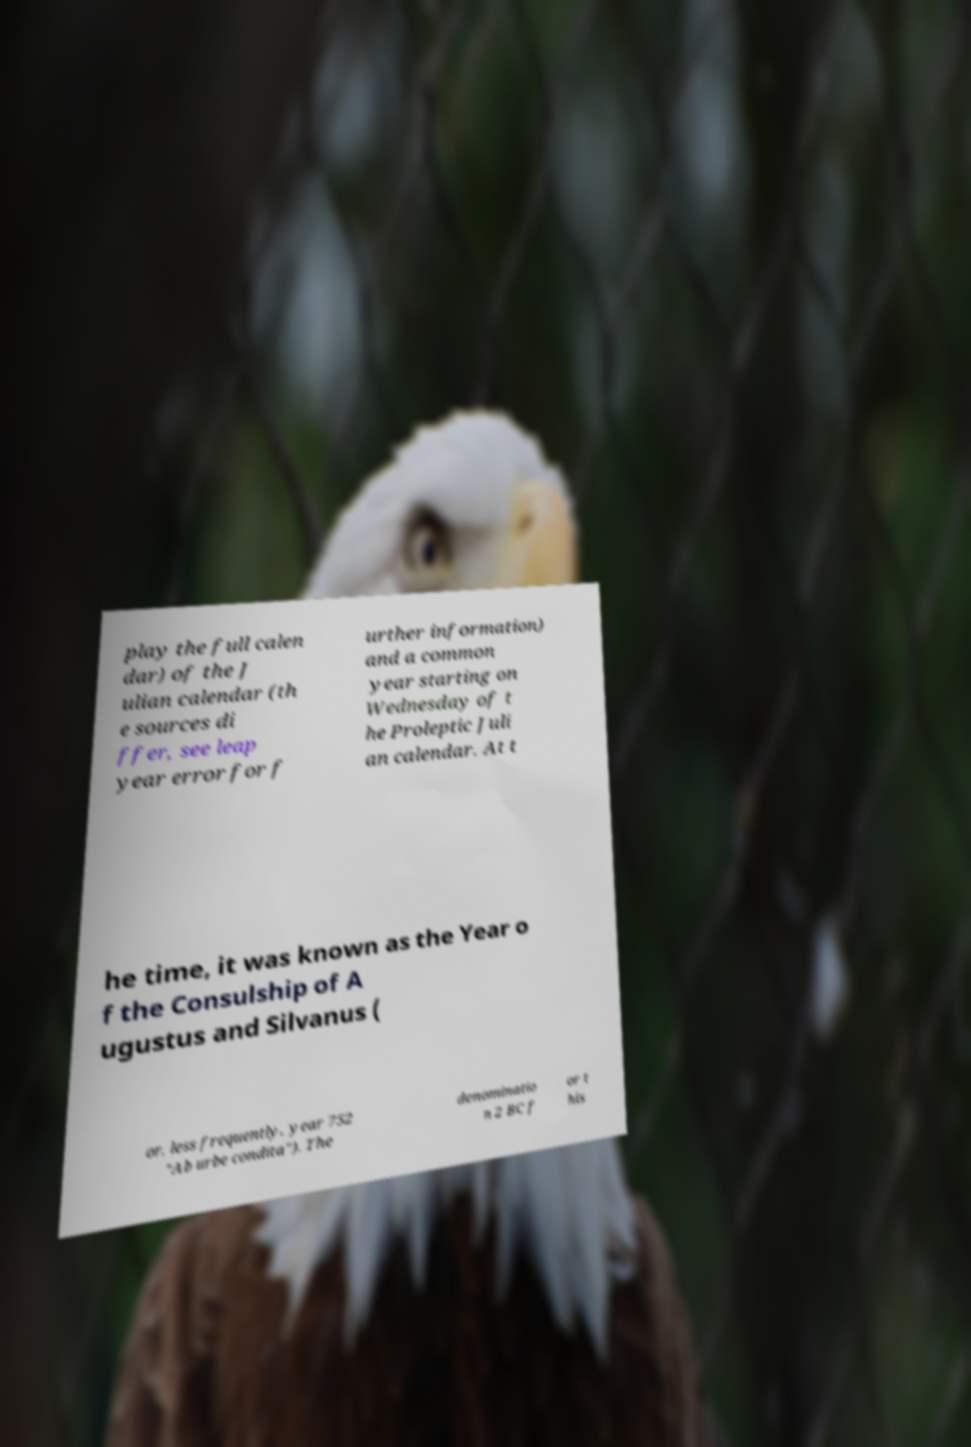What messages or text are displayed in this image? I need them in a readable, typed format. play the full calen dar) of the J ulian calendar (th e sources di ffer, see leap year error for f urther information) and a common year starting on Wednesday of t he Proleptic Juli an calendar. At t he time, it was known as the Year o f the Consulship of A ugustus and Silvanus ( or, less frequently, year 752 "Ab urbe condita"). The denominatio n 2 BC f or t his 